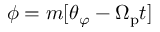<formula> <loc_0><loc_0><loc_500><loc_500>\phi = m [ \theta _ { \varphi } - \Omega _ { p } t ]</formula> 